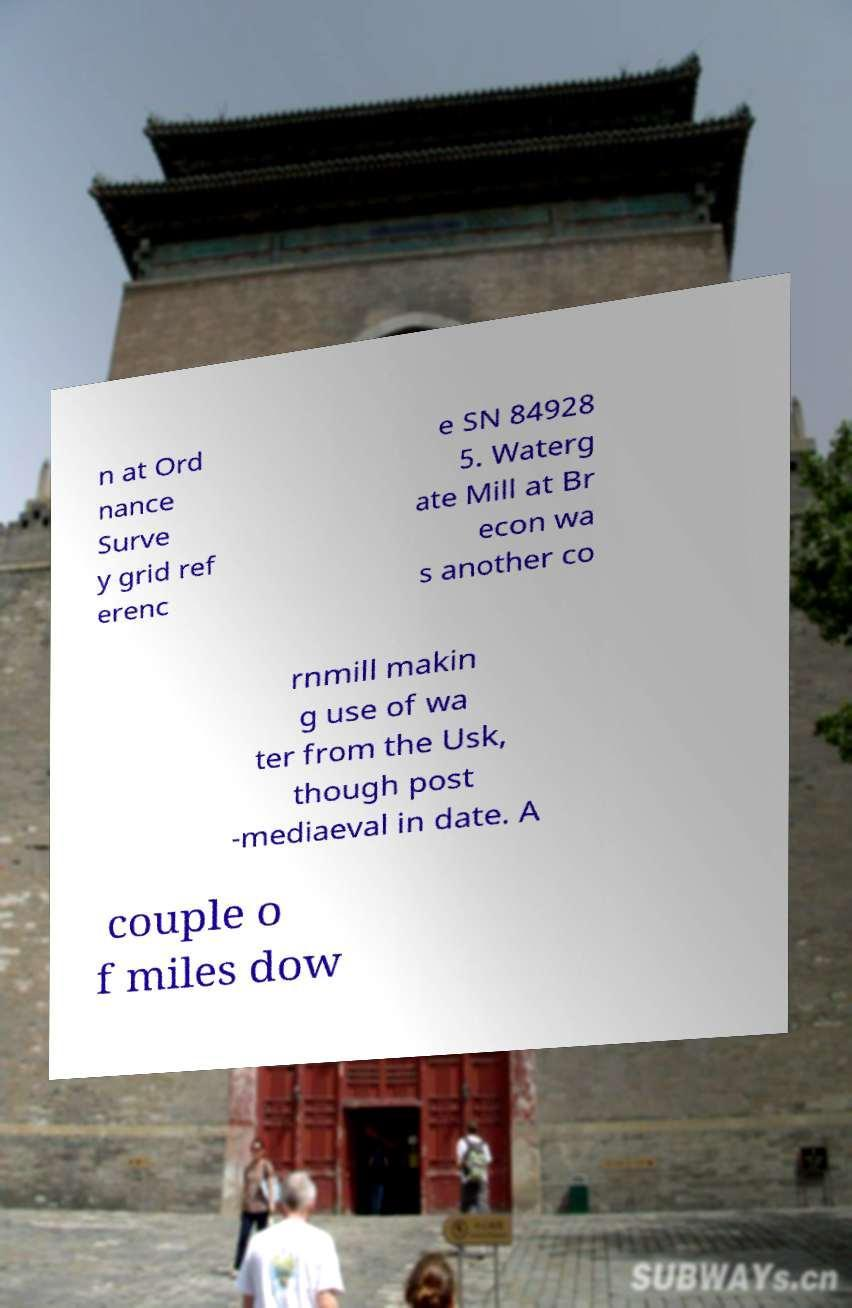For documentation purposes, I need the text within this image transcribed. Could you provide that? n at Ord nance Surve y grid ref erenc e SN 84928 5. Waterg ate Mill at Br econ wa s another co rnmill makin g use of wa ter from the Usk, though post -mediaeval in date. A couple o f miles dow 